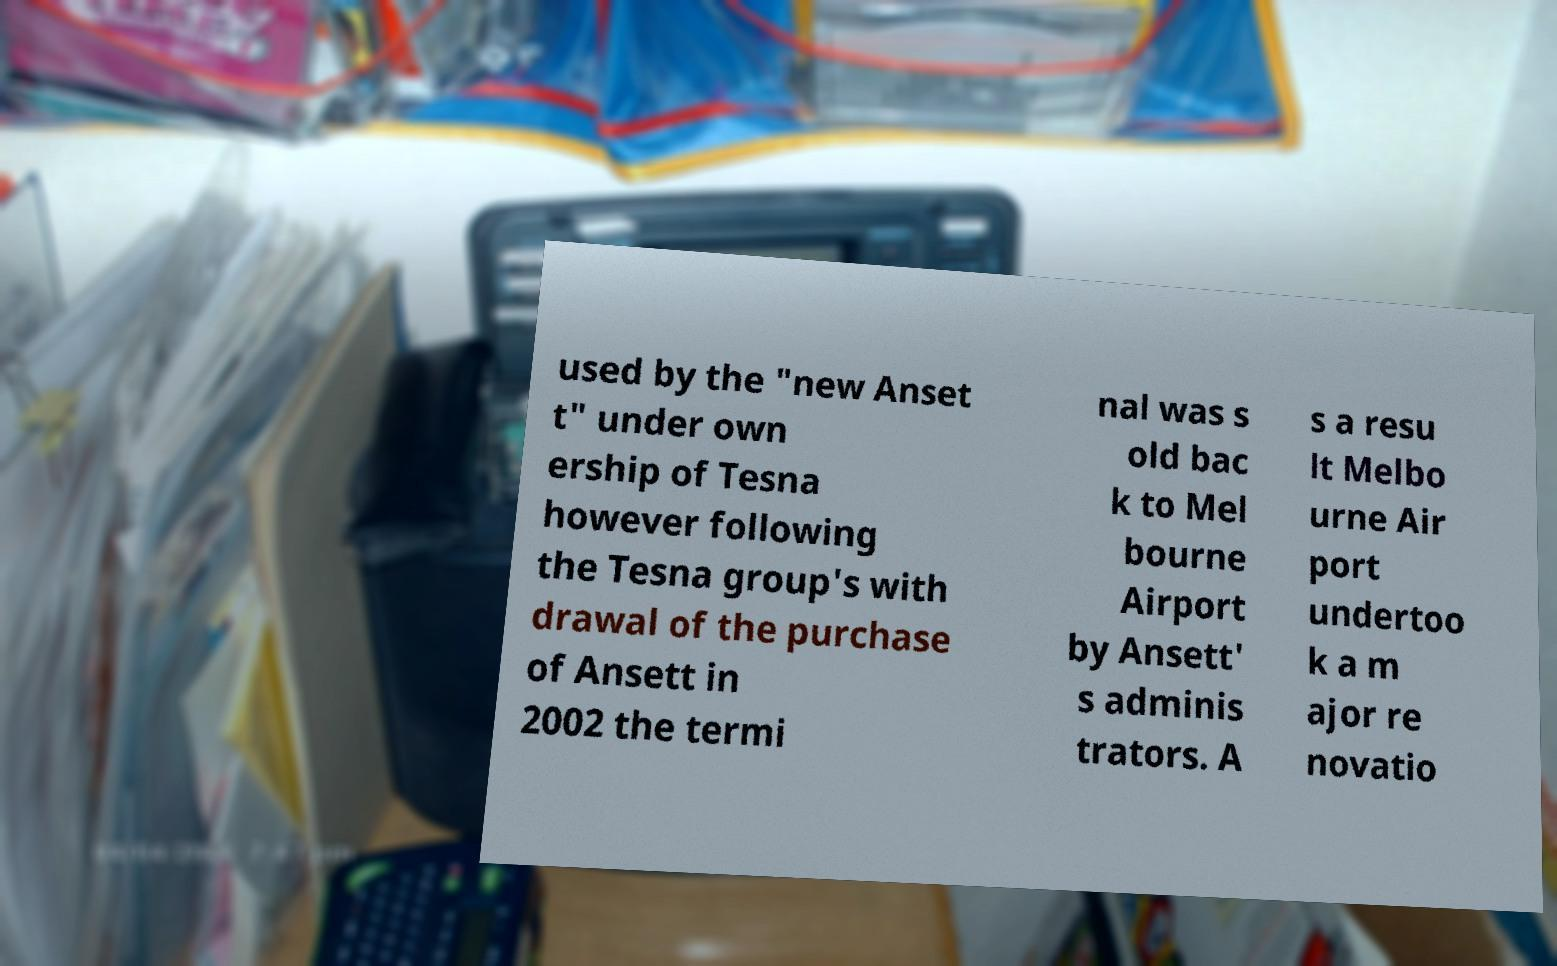Please identify and transcribe the text found in this image. used by the "new Anset t" under own ership of Tesna however following the Tesna group's with drawal of the purchase of Ansett in 2002 the termi nal was s old bac k to Mel bourne Airport by Ansett' s adminis trators. A s a resu lt Melbo urne Air port undertoo k a m ajor re novatio 